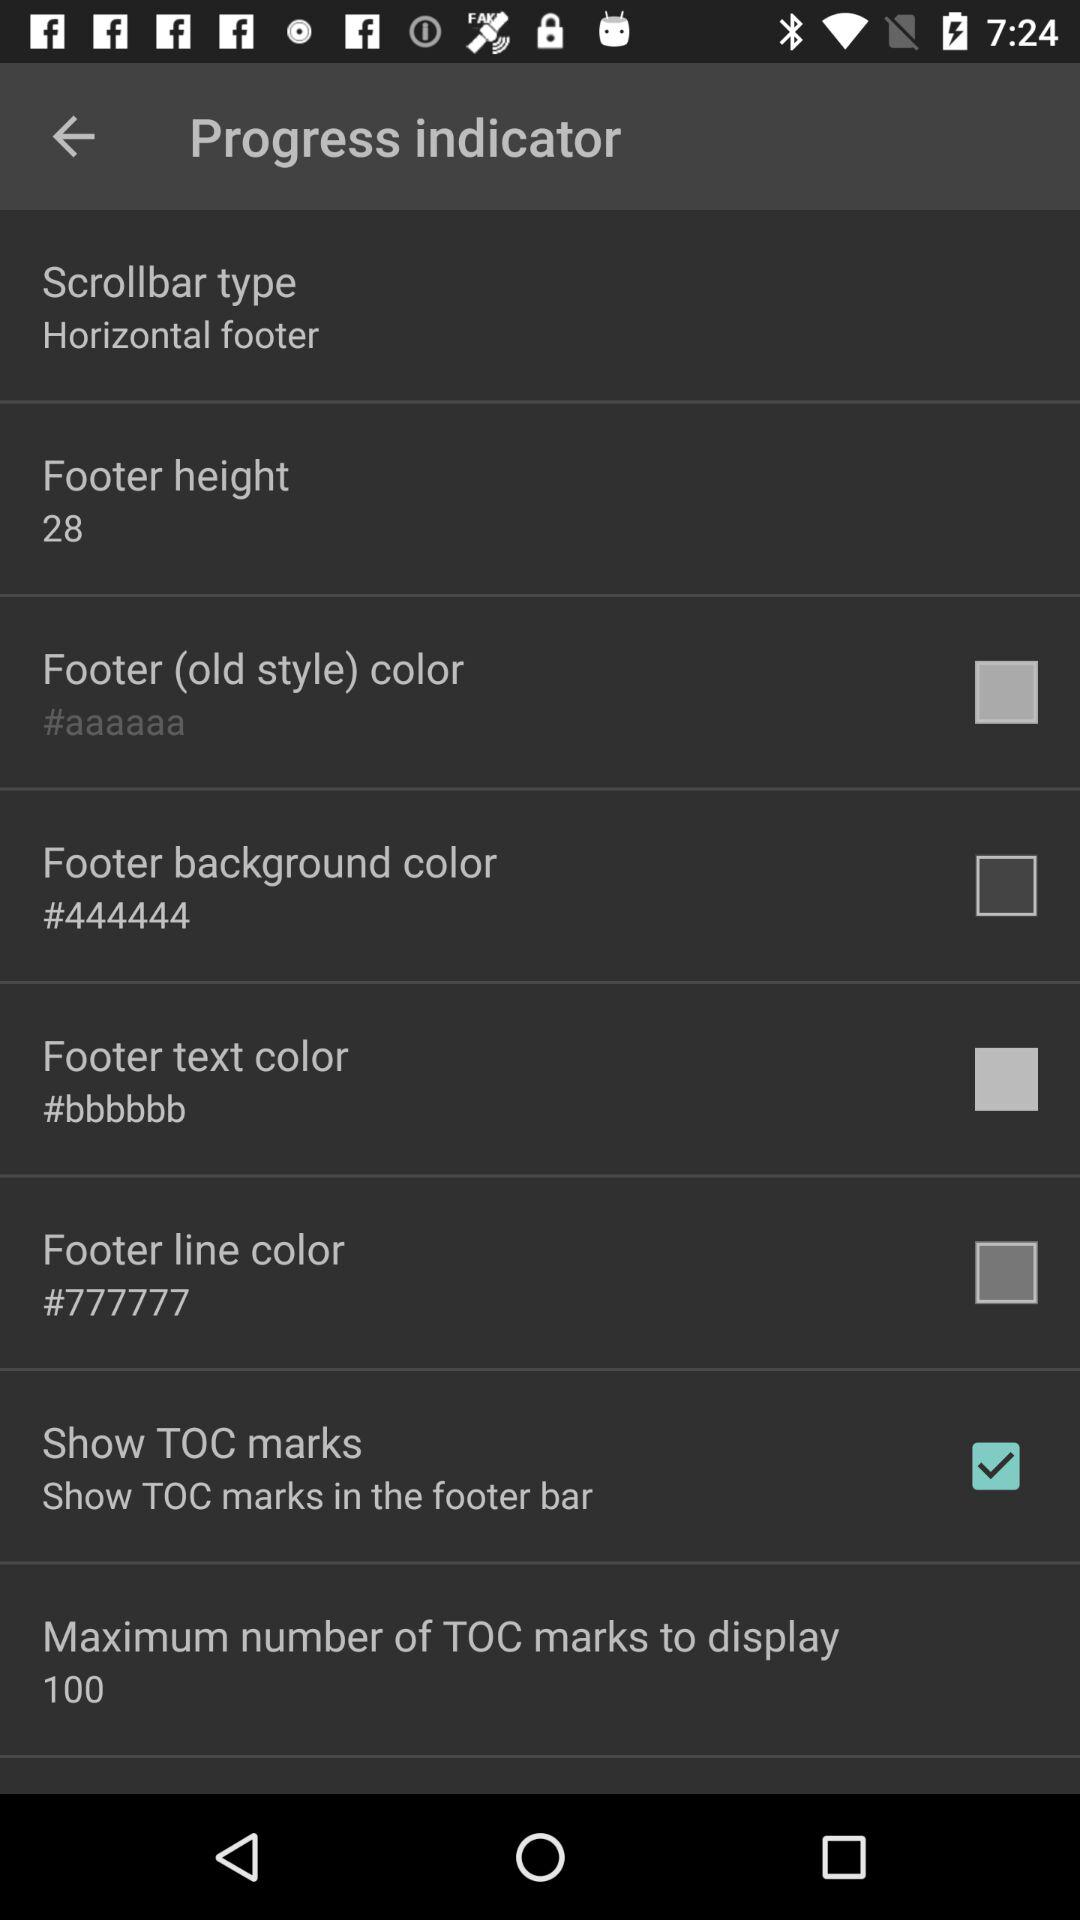What is the status of "Show TOC marks"? The status of "Show TOC marks" is "on". 